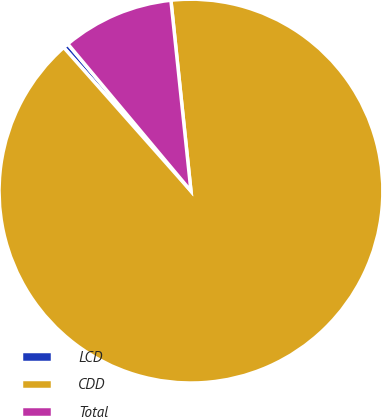<chart> <loc_0><loc_0><loc_500><loc_500><pie_chart><fcel>LCD<fcel>CDD<fcel>Total<nl><fcel>0.45%<fcel>90.12%<fcel>9.42%<nl></chart> 